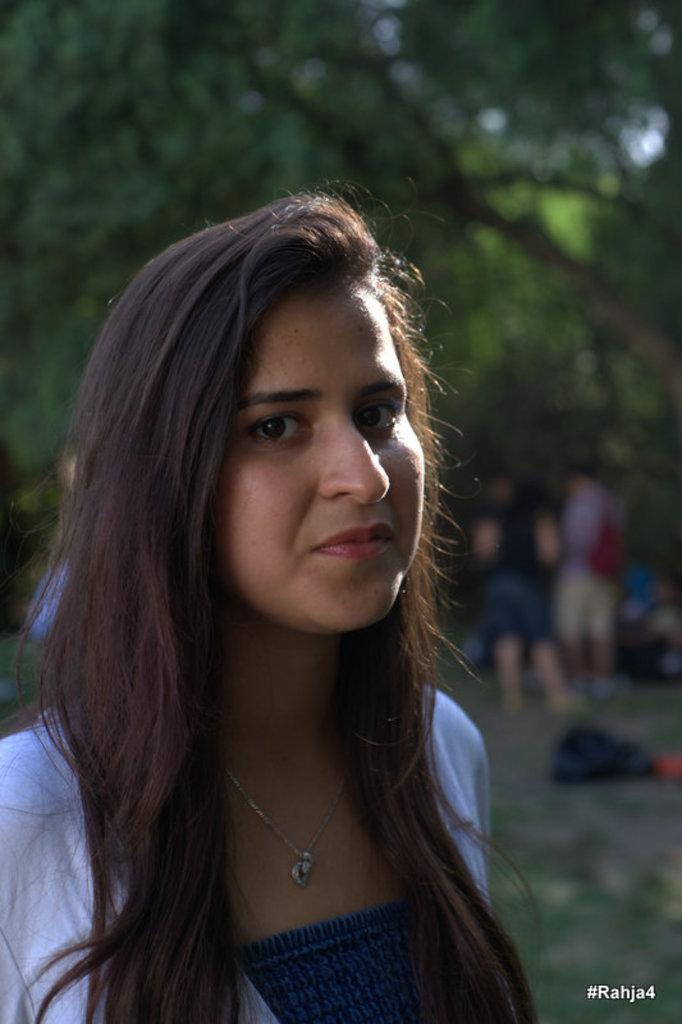What is the main subject of the image? There is a lady standing in the image. What can be seen in the background of the image? There are trees and people visible in the background of the image. What type of mint can be seen growing near the lady in the image? There is no mint plant visible near the lady in the image. How many cents are visible on the ground in the image? There are no cents visible on the ground in the image. 